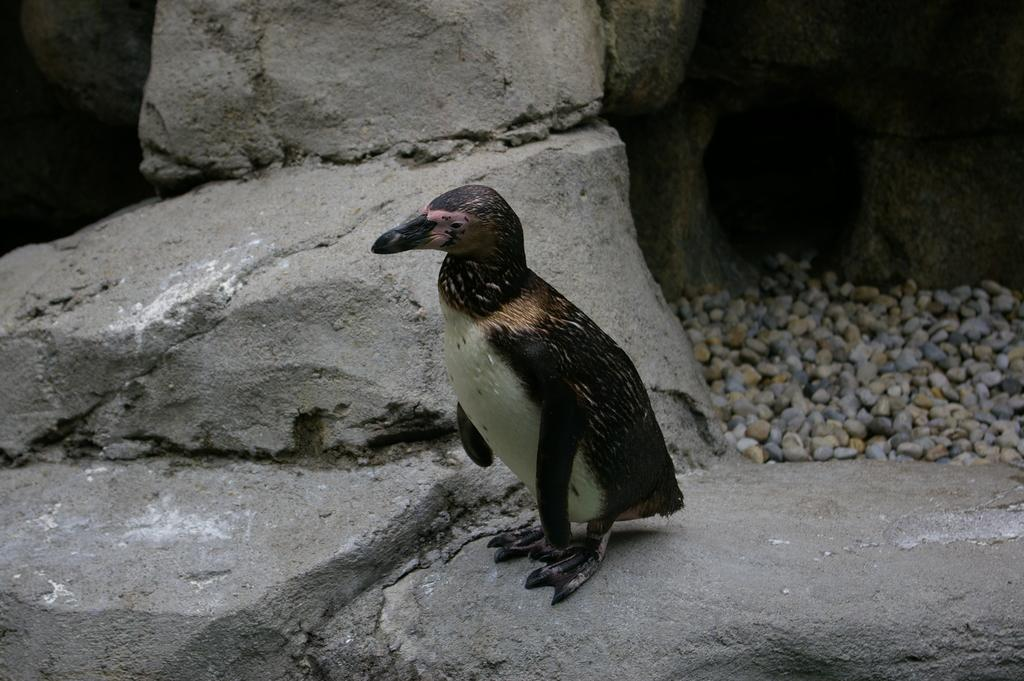What type of animal is in the image? There is a bird in the image. Where is the bird located? The bird is on a rock. What can be seen on the right side of the image? There are stones on the right side of the image. What type of glue is the bird using to stick the stones together in the image? There is no glue or stones being stuck together in the image; the bird is simply perched on a rock. 